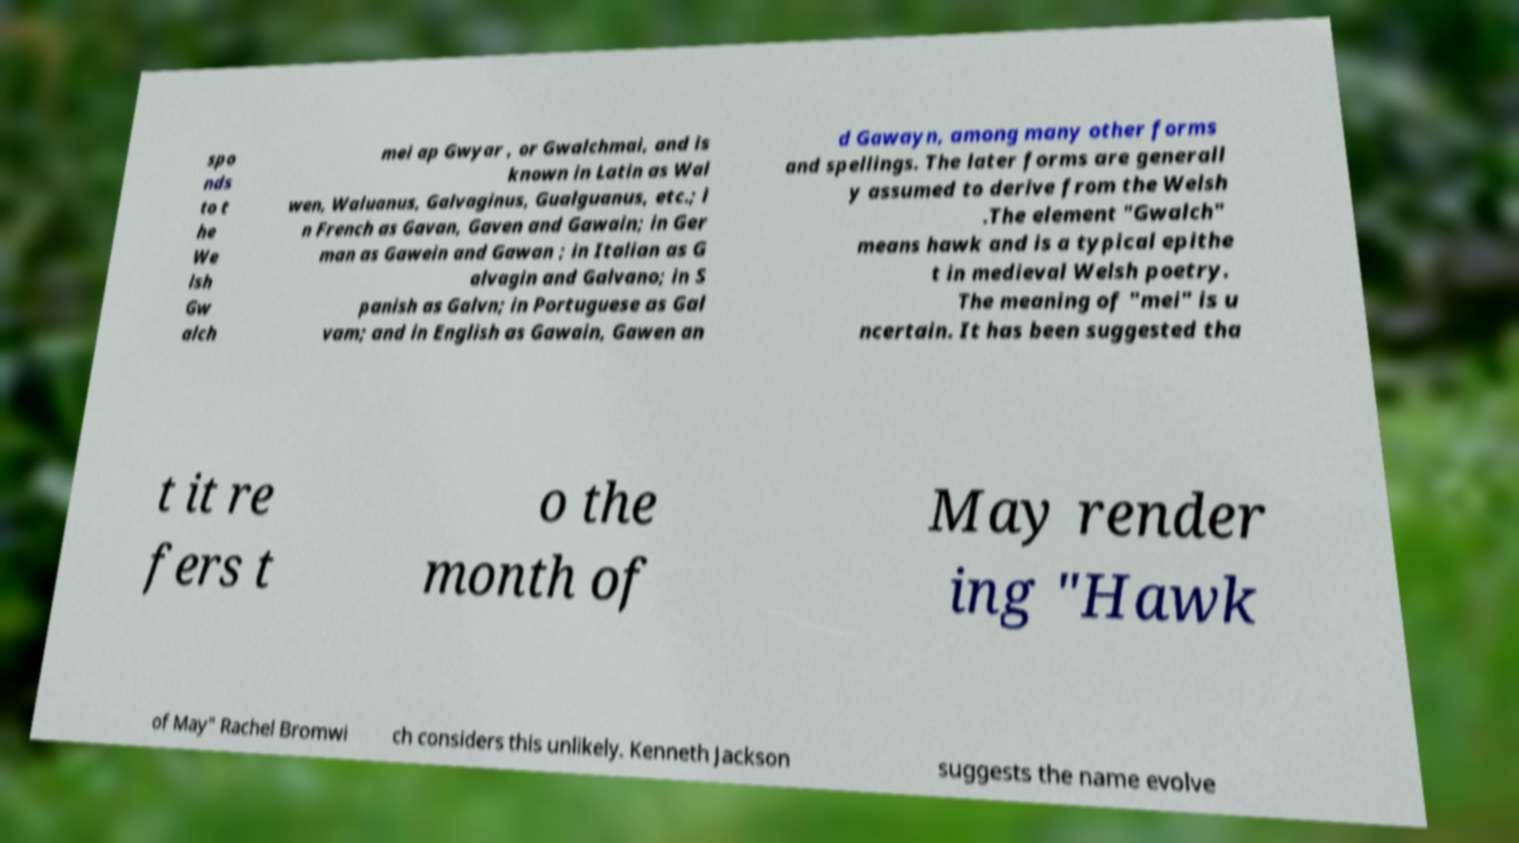Can you accurately transcribe the text from the provided image for me? spo nds to t he We lsh Gw alch mei ap Gwyar , or Gwalchmai, and is known in Latin as Wal wen, Waluanus, Galvaginus, Gualguanus, etc.; i n French as Gavan, Gaven and Gawain; in Ger man as Gawein and Gawan ; in Italian as G alvagin and Galvano; in S panish as Galvn; in Portuguese as Gal vam; and in English as Gawain, Gawen an d Gawayn, among many other forms and spellings. The later forms are generall y assumed to derive from the Welsh .The element "Gwalch" means hawk and is a typical epithe t in medieval Welsh poetry. The meaning of "mei" is u ncertain. It has been suggested tha t it re fers t o the month of May render ing "Hawk of May" Rachel Bromwi ch considers this unlikely. Kenneth Jackson suggests the name evolve 